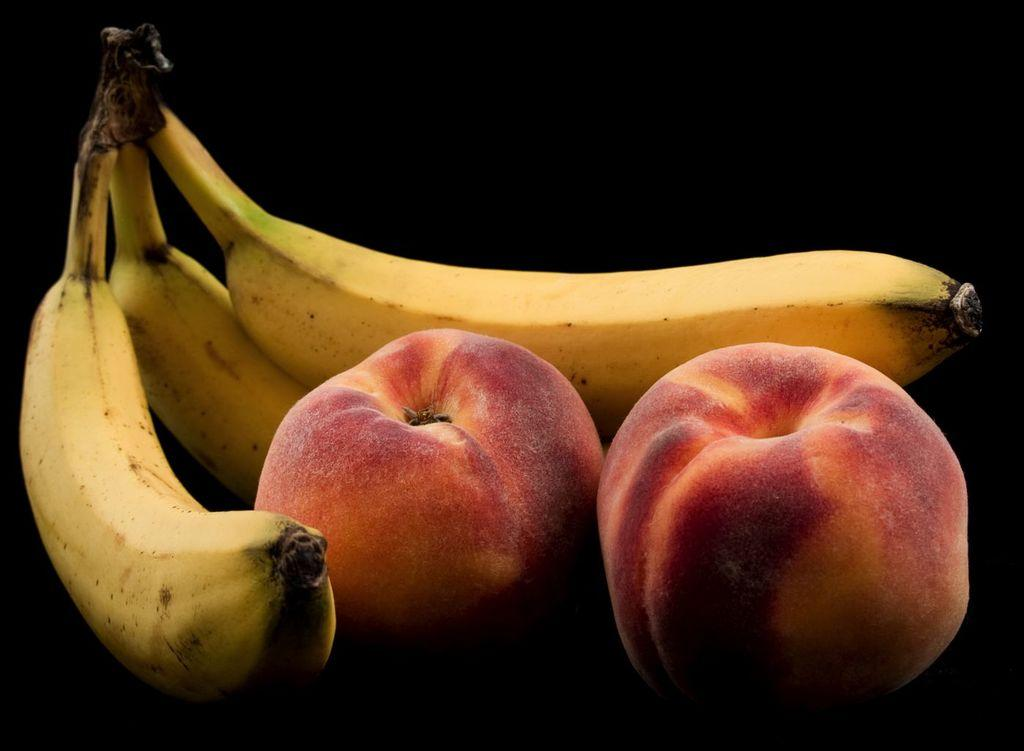How many bananas are visible in the image? There are three bananas in the image. What other type of fruit can be seen in the image? There are apples in the image. What color is the background of the image? The background of the image is black. Can you tell me how many tigers are visible in the image? There are no tigers present in the image; it features bananas and apples. What type of yard is visible in the image? There is no yard present in the image; it features bananas and apples against a black background. 